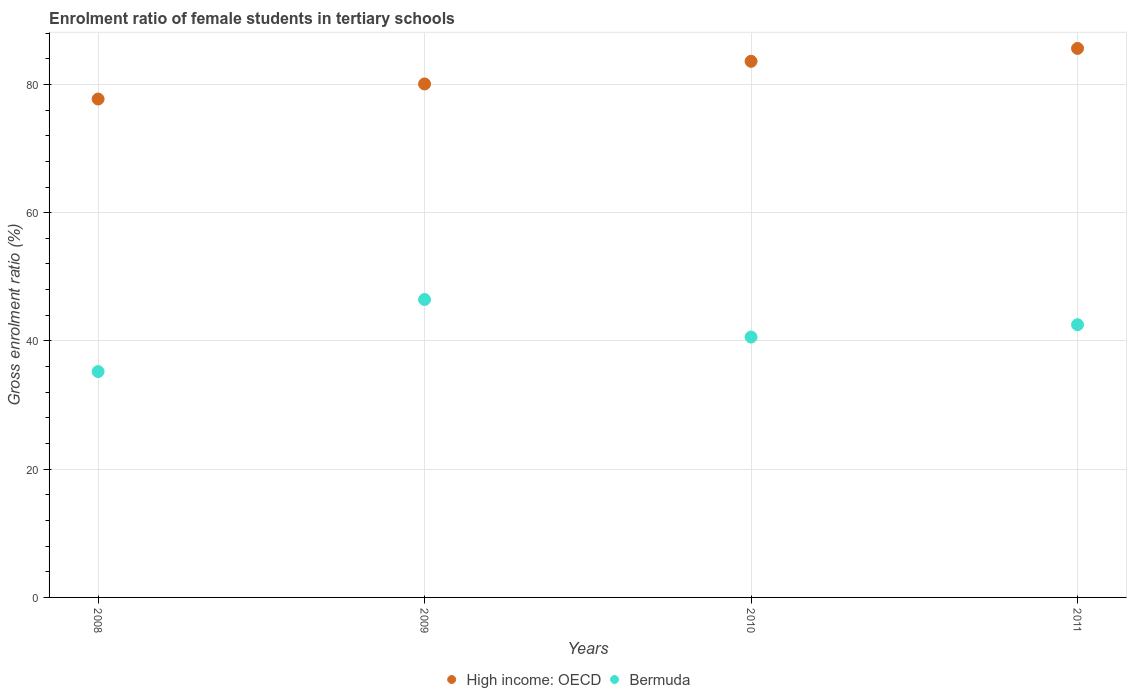What is the enrolment ratio of female students in tertiary schools in Bermuda in 2009?
Make the answer very short. 46.46. Across all years, what is the maximum enrolment ratio of female students in tertiary schools in High income: OECD?
Make the answer very short. 85.61. Across all years, what is the minimum enrolment ratio of female students in tertiary schools in High income: OECD?
Ensure brevity in your answer.  77.72. In which year was the enrolment ratio of female students in tertiary schools in Bermuda minimum?
Keep it short and to the point. 2008. What is the total enrolment ratio of female students in tertiary schools in Bermuda in the graph?
Make the answer very short. 164.81. What is the difference between the enrolment ratio of female students in tertiary schools in High income: OECD in 2009 and that in 2010?
Make the answer very short. -3.53. What is the difference between the enrolment ratio of female students in tertiary schools in High income: OECD in 2008 and the enrolment ratio of female students in tertiary schools in Bermuda in 2010?
Ensure brevity in your answer.  37.11. What is the average enrolment ratio of female students in tertiary schools in Bermuda per year?
Give a very brief answer. 41.2. In the year 2011, what is the difference between the enrolment ratio of female students in tertiary schools in High income: OECD and enrolment ratio of female students in tertiary schools in Bermuda?
Your response must be concise. 43.09. In how many years, is the enrolment ratio of female students in tertiary schools in Bermuda greater than 40 %?
Provide a short and direct response. 3. What is the ratio of the enrolment ratio of female students in tertiary schools in High income: OECD in 2010 to that in 2011?
Ensure brevity in your answer.  0.98. Is the enrolment ratio of female students in tertiary schools in Bermuda in 2009 less than that in 2011?
Make the answer very short. No. What is the difference between the highest and the second highest enrolment ratio of female students in tertiary schools in High income: OECD?
Provide a short and direct response. 2.01. What is the difference between the highest and the lowest enrolment ratio of female students in tertiary schools in High income: OECD?
Offer a very short reply. 7.89. In how many years, is the enrolment ratio of female students in tertiary schools in Bermuda greater than the average enrolment ratio of female students in tertiary schools in Bermuda taken over all years?
Your answer should be compact. 2. Does the enrolment ratio of female students in tertiary schools in Bermuda monotonically increase over the years?
Your response must be concise. No. Is the enrolment ratio of female students in tertiary schools in Bermuda strictly greater than the enrolment ratio of female students in tertiary schools in High income: OECD over the years?
Offer a very short reply. No. Is the enrolment ratio of female students in tertiary schools in Bermuda strictly less than the enrolment ratio of female students in tertiary schools in High income: OECD over the years?
Your response must be concise. Yes. What is the difference between two consecutive major ticks on the Y-axis?
Your answer should be compact. 20. Does the graph contain any zero values?
Keep it short and to the point. No. Does the graph contain grids?
Make the answer very short. Yes. What is the title of the graph?
Your answer should be compact. Enrolment ratio of female students in tertiary schools. What is the label or title of the X-axis?
Provide a succinct answer. Years. What is the label or title of the Y-axis?
Your answer should be very brief. Gross enrolment ratio (%). What is the Gross enrolment ratio (%) of High income: OECD in 2008?
Your answer should be very brief. 77.72. What is the Gross enrolment ratio (%) of Bermuda in 2008?
Your answer should be compact. 35.22. What is the Gross enrolment ratio (%) in High income: OECD in 2009?
Offer a very short reply. 80.07. What is the Gross enrolment ratio (%) of Bermuda in 2009?
Make the answer very short. 46.46. What is the Gross enrolment ratio (%) of High income: OECD in 2010?
Ensure brevity in your answer.  83.6. What is the Gross enrolment ratio (%) of Bermuda in 2010?
Offer a terse response. 40.61. What is the Gross enrolment ratio (%) of High income: OECD in 2011?
Give a very brief answer. 85.61. What is the Gross enrolment ratio (%) of Bermuda in 2011?
Give a very brief answer. 42.53. Across all years, what is the maximum Gross enrolment ratio (%) in High income: OECD?
Make the answer very short. 85.61. Across all years, what is the maximum Gross enrolment ratio (%) in Bermuda?
Offer a terse response. 46.46. Across all years, what is the minimum Gross enrolment ratio (%) in High income: OECD?
Your response must be concise. 77.72. Across all years, what is the minimum Gross enrolment ratio (%) in Bermuda?
Provide a succinct answer. 35.22. What is the total Gross enrolment ratio (%) in High income: OECD in the graph?
Offer a terse response. 327.01. What is the total Gross enrolment ratio (%) of Bermuda in the graph?
Provide a succinct answer. 164.81. What is the difference between the Gross enrolment ratio (%) in High income: OECD in 2008 and that in 2009?
Offer a very short reply. -2.35. What is the difference between the Gross enrolment ratio (%) in Bermuda in 2008 and that in 2009?
Provide a short and direct response. -11.24. What is the difference between the Gross enrolment ratio (%) of High income: OECD in 2008 and that in 2010?
Make the answer very short. -5.88. What is the difference between the Gross enrolment ratio (%) in Bermuda in 2008 and that in 2010?
Offer a terse response. -5.39. What is the difference between the Gross enrolment ratio (%) in High income: OECD in 2008 and that in 2011?
Your answer should be compact. -7.89. What is the difference between the Gross enrolment ratio (%) in Bermuda in 2008 and that in 2011?
Give a very brief answer. -7.31. What is the difference between the Gross enrolment ratio (%) of High income: OECD in 2009 and that in 2010?
Your answer should be compact. -3.53. What is the difference between the Gross enrolment ratio (%) of Bermuda in 2009 and that in 2010?
Your response must be concise. 5.85. What is the difference between the Gross enrolment ratio (%) in High income: OECD in 2009 and that in 2011?
Provide a succinct answer. -5.54. What is the difference between the Gross enrolment ratio (%) in Bermuda in 2009 and that in 2011?
Provide a succinct answer. 3.93. What is the difference between the Gross enrolment ratio (%) in High income: OECD in 2010 and that in 2011?
Make the answer very short. -2.01. What is the difference between the Gross enrolment ratio (%) in Bermuda in 2010 and that in 2011?
Give a very brief answer. -1.92. What is the difference between the Gross enrolment ratio (%) in High income: OECD in 2008 and the Gross enrolment ratio (%) in Bermuda in 2009?
Provide a succinct answer. 31.27. What is the difference between the Gross enrolment ratio (%) in High income: OECD in 2008 and the Gross enrolment ratio (%) in Bermuda in 2010?
Give a very brief answer. 37.11. What is the difference between the Gross enrolment ratio (%) in High income: OECD in 2008 and the Gross enrolment ratio (%) in Bermuda in 2011?
Your response must be concise. 35.2. What is the difference between the Gross enrolment ratio (%) of High income: OECD in 2009 and the Gross enrolment ratio (%) of Bermuda in 2010?
Your answer should be compact. 39.46. What is the difference between the Gross enrolment ratio (%) in High income: OECD in 2009 and the Gross enrolment ratio (%) in Bermuda in 2011?
Offer a very short reply. 37.54. What is the difference between the Gross enrolment ratio (%) in High income: OECD in 2010 and the Gross enrolment ratio (%) in Bermuda in 2011?
Provide a succinct answer. 41.08. What is the average Gross enrolment ratio (%) of High income: OECD per year?
Offer a terse response. 81.75. What is the average Gross enrolment ratio (%) of Bermuda per year?
Provide a succinct answer. 41.2. In the year 2008, what is the difference between the Gross enrolment ratio (%) in High income: OECD and Gross enrolment ratio (%) in Bermuda?
Ensure brevity in your answer.  42.5. In the year 2009, what is the difference between the Gross enrolment ratio (%) of High income: OECD and Gross enrolment ratio (%) of Bermuda?
Ensure brevity in your answer.  33.61. In the year 2010, what is the difference between the Gross enrolment ratio (%) of High income: OECD and Gross enrolment ratio (%) of Bermuda?
Your response must be concise. 43. In the year 2011, what is the difference between the Gross enrolment ratio (%) of High income: OECD and Gross enrolment ratio (%) of Bermuda?
Ensure brevity in your answer.  43.09. What is the ratio of the Gross enrolment ratio (%) of High income: OECD in 2008 to that in 2009?
Your answer should be very brief. 0.97. What is the ratio of the Gross enrolment ratio (%) of Bermuda in 2008 to that in 2009?
Keep it short and to the point. 0.76. What is the ratio of the Gross enrolment ratio (%) of High income: OECD in 2008 to that in 2010?
Offer a very short reply. 0.93. What is the ratio of the Gross enrolment ratio (%) of Bermuda in 2008 to that in 2010?
Keep it short and to the point. 0.87. What is the ratio of the Gross enrolment ratio (%) of High income: OECD in 2008 to that in 2011?
Your answer should be very brief. 0.91. What is the ratio of the Gross enrolment ratio (%) in Bermuda in 2008 to that in 2011?
Your answer should be very brief. 0.83. What is the ratio of the Gross enrolment ratio (%) in High income: OECD in 2009 to that in 2010?
Your response must be concise. 0.96. What is the ratio of the Gross enrolment ratio (%) in Bermuda in 2009 to that in 2010?
Offer a very short reply. 1.14. What is the ratio of the Gross enrolment ratio (%) of High income: OECD in 2009 to that in 2011?
Offer a very short reply. 0.94. What is the ratio of the Gross enrolment ratio (%) of Bermuda in 2009 to that in 2011?
Give a very brief answer. 1.09. What is the ratio of the Gross enrolment ratio (%) of High income: OECD in 2010 to that in 2011?
Offer a very short reply. 0.98. What is the ratio of the Gross enrolment ratio (%) in Bermuda in 2010 to that in 2011?
Offer a terse response. 0.95. What is the difference between the highest and the second highest Gross enrolment ratio (%) of High income: OECD?
Make the answer very short. 2.01. What is the difference between the highest and the second highest Gross enrolment ratio (%) of Bermuda?
Give a very brief answer. 3.93. What is the difference between the highest and the lowest Gross enrolment ratio (%) in High income: OECD?
Make the answer very short. 7.89. What is the difference between the highest and the lowest Gross enrolment ratio (%) in Bermuda?
Offer a terse response. 11.24. 